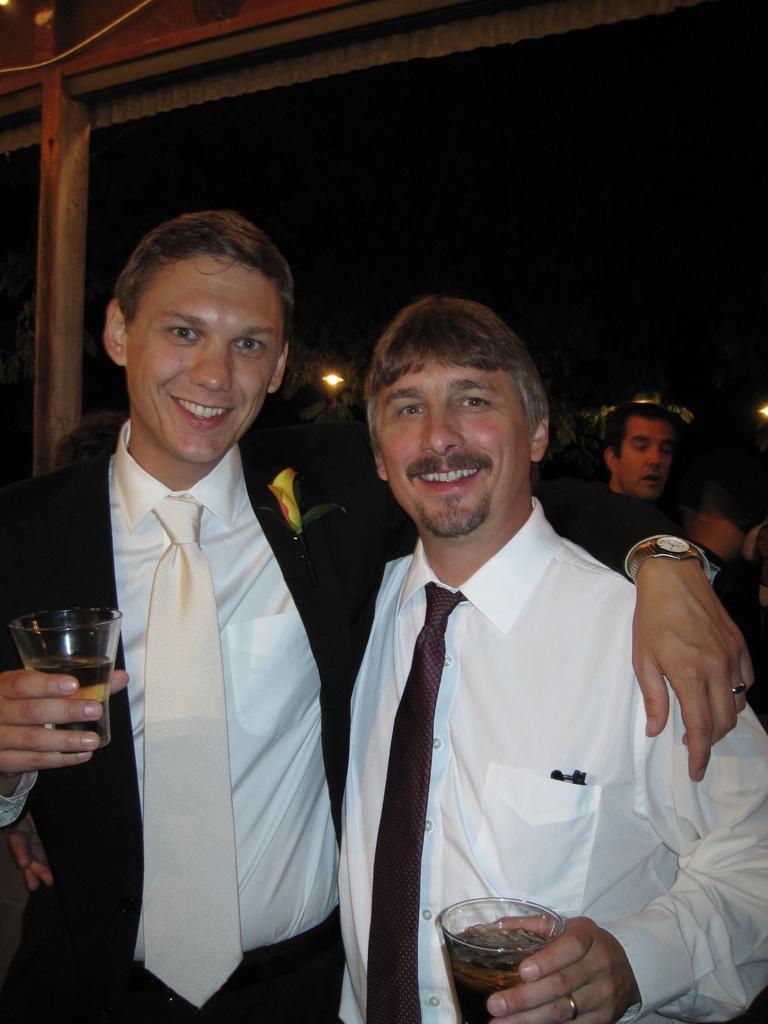Could you give a brief overview of what you see in this image? It looks like a party there are two men standing in the front and both of them are holding glasses with drink and they are smiling. Behind these men there is another person standing on the right side and the background is dark, there is a small light visible from the window. 